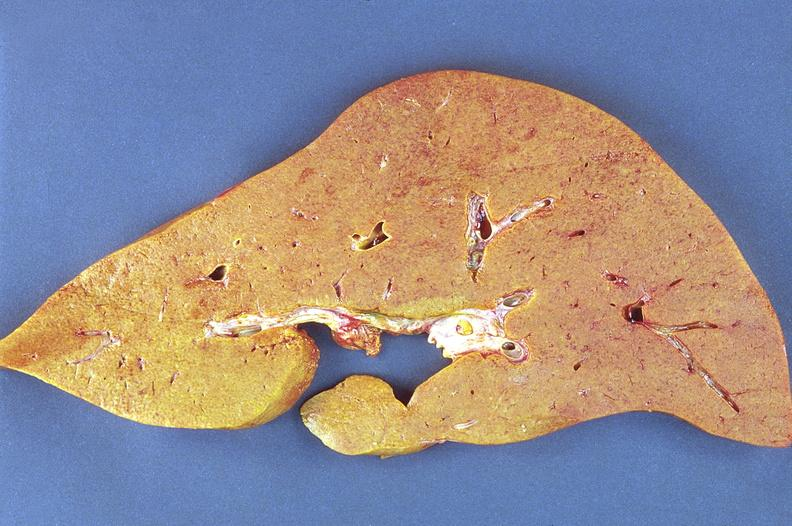s hepatobiliary present?
Answer the question using a single word or phrase. Yes 